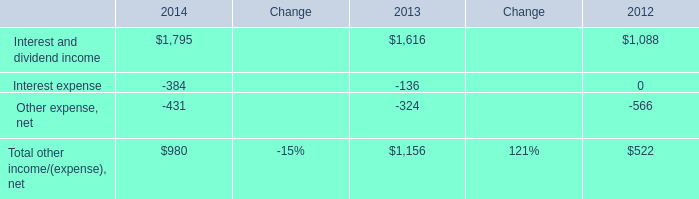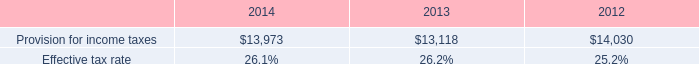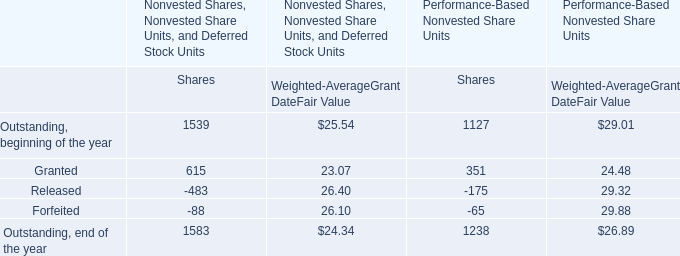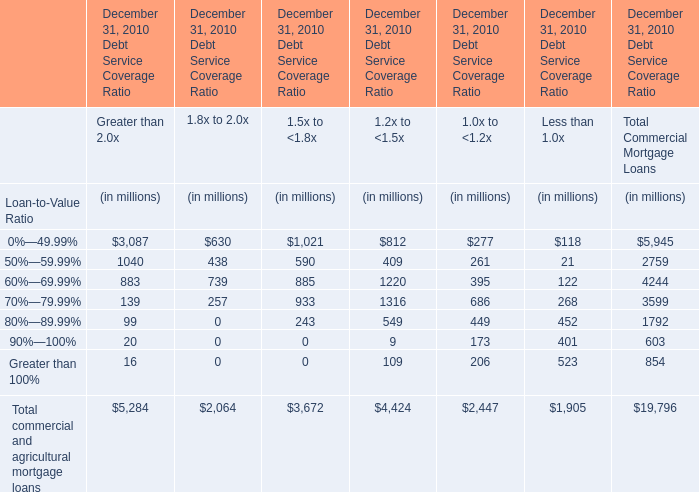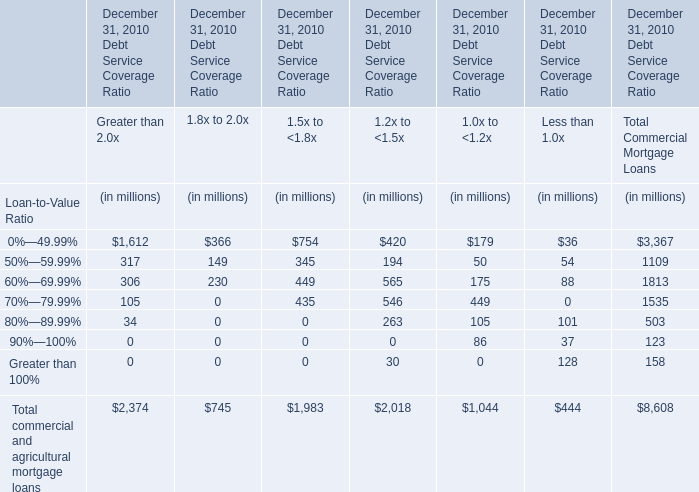What's the total amount of the Interest and dividend income in the years where Provision for income taxes is greater than 0? 
Computations: ((1795 + 1616) + 1088)
Answer: 4499.0. 